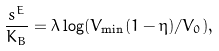Convert formula to latex. <formula><loc_0><loc_0><loc_500><loc_500>\frac { s ^ { E } } { K _ { B } } = \lambda \log ( V _ { \min } ( 1 - \eta ) / V _ { 0 } ) ,</formula> 